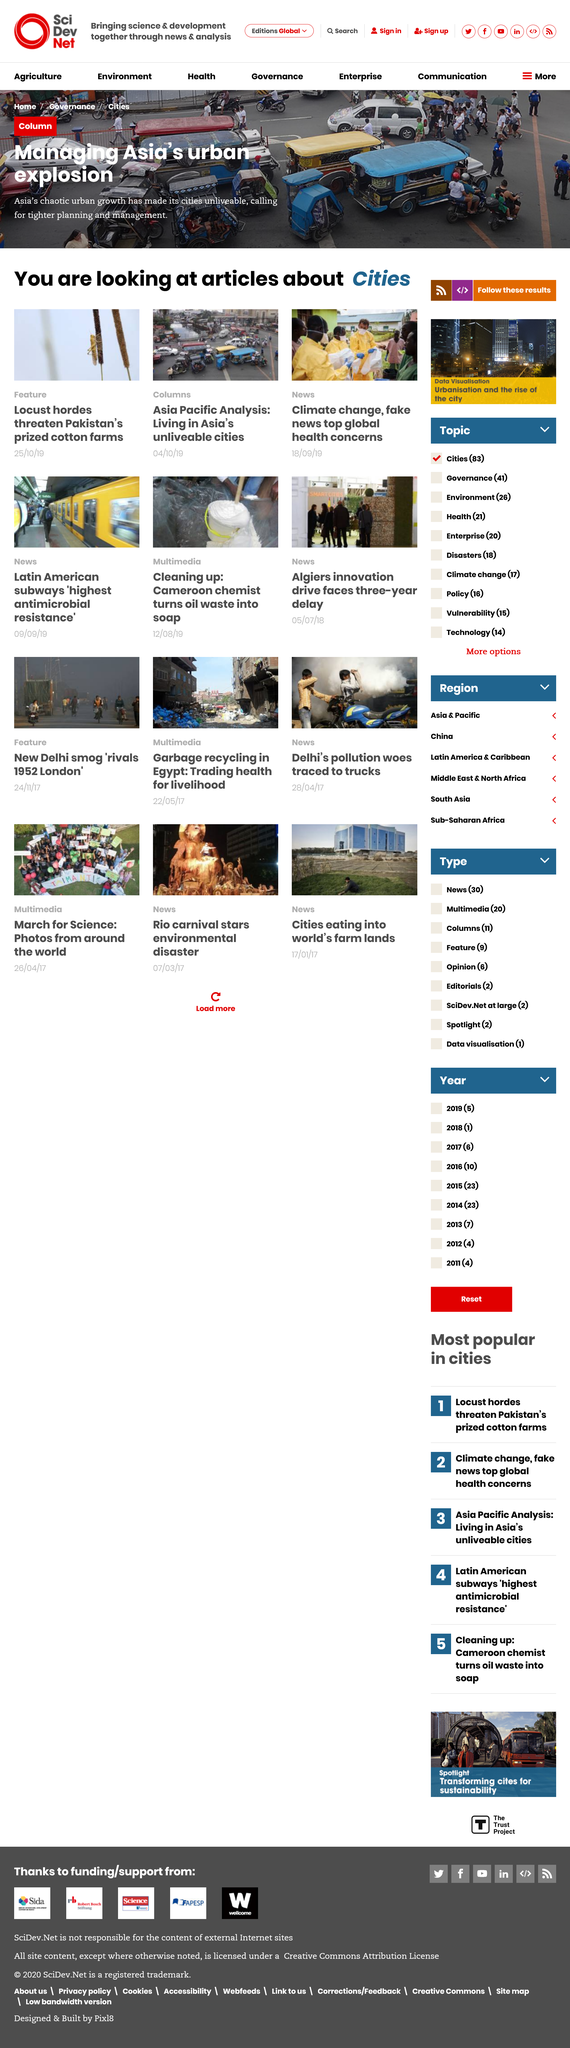Highlight a few significant elements in this photo. Locusts are posing a significant threat to Pakistan's cotton farms, which could have a detrimental impact on the country's economy and food security. The living conditions in Asian cities are unlivable. What is depicted in this image? A car crash on a congested road can be seen. 